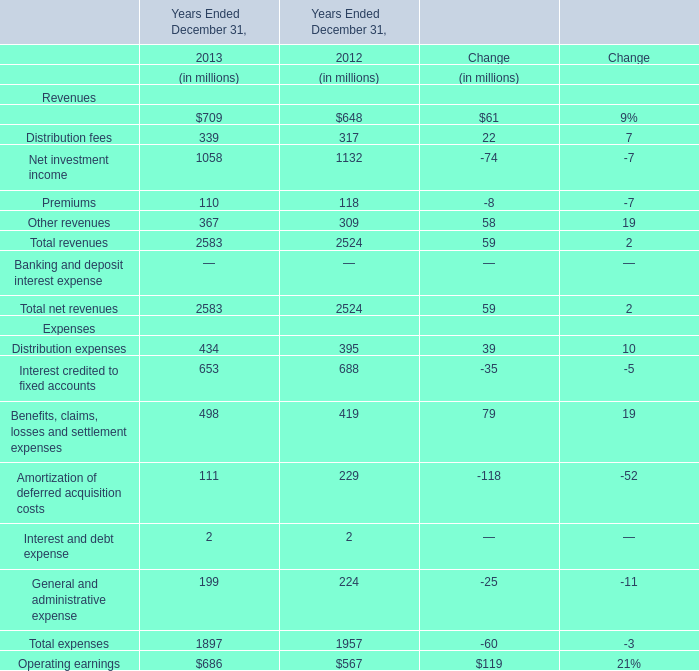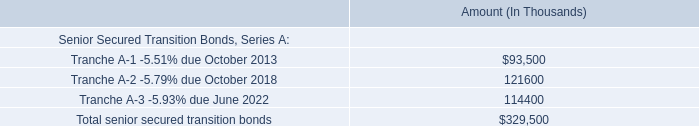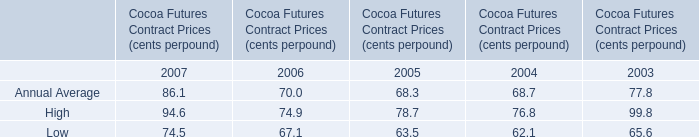what was the ratio of the scheduled principal payments in 2017 for tranche a-2 to a-3 
Computations: (23.6 / 4)
Answer: 5.9. 